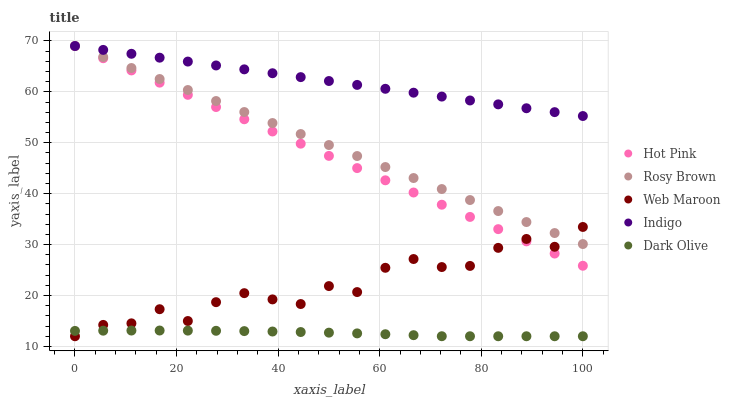Does Dark Olive have the minimum area under the curve?
Answer yes or no. Yes. Does Indigo have the maximum area under the curve?
Answer yes or no. Yes. Does Rosy Brown have the minimum area under the curve?
Answer yes or no. No. Does Rosy Brown have the maximum area under the curve?
Answer yes or no. No. Is Rosy Brown the smoothest?
Answer yes or no. Yes. Is Web Maroon the roughest?
Answer yes or no. Yes. Is Indigo the smoothest?
Answer yes or no. No. Is Indigo the roughest?
Answer yes or no. No. Does Dark Olive have the lowest value?
Answer yes or no. Yes. Does Rosy Brown have the lowest value?
Answer yes or no. No. Does Hot Pink have the highest value?
Answer yes or no. Yes. Does Web Maroon have the highest value?
Answer yes or no. No. Is Dark Olive less than Rosy Brown?
Answer yes or no. Yes. Is Indigo greater than Dark Olive?
Answer yes or no. Yes. Does Hot Pink intersect Indigo?
Answer yes or no. Yes. Is Hot Pink less than Indigo?
Answer yes or no. No. Is Hot Pink greater than Indigo?
Answer yes or no. No. Does Dark Olive intersect Rosy Brown?
Answer yes or no. No. 